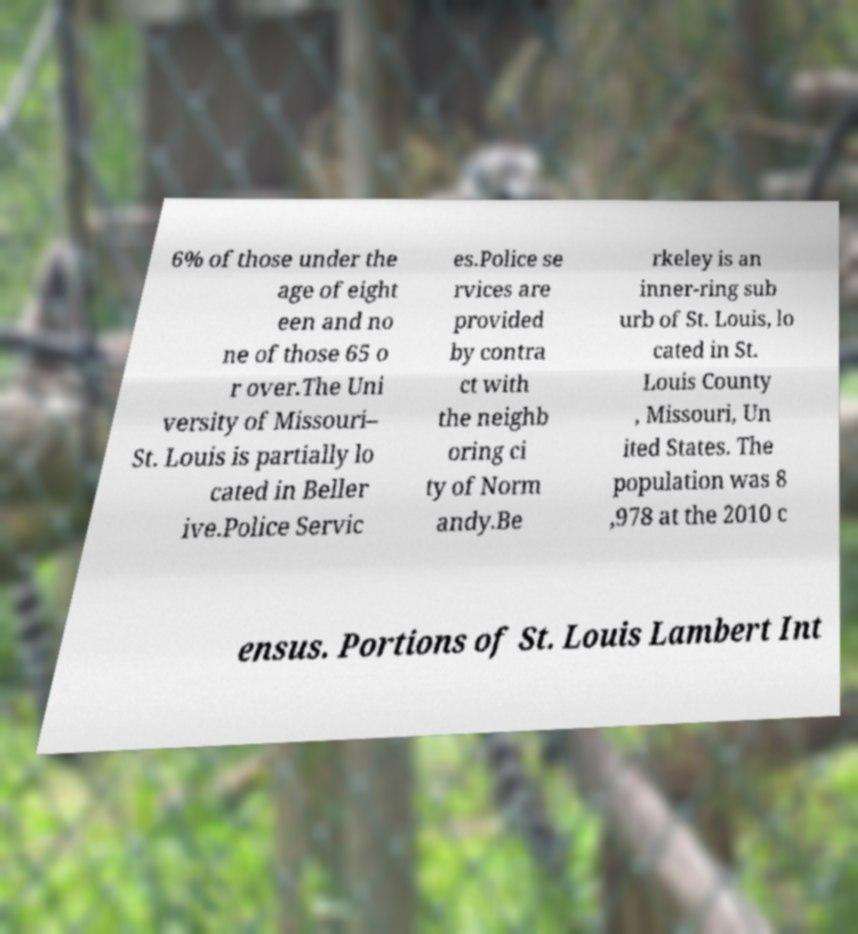For documentation purposes, I need the text within this image transcribed. Could you provide that? 6% of those under the age of eight een and no ne of those 65 o r over.The Uni versity of Missouri– St. Louis is partially lo cated in Beller ive.Police Servic es.Police se rvices are provided by contra ct with the neighb oring ci ty of Norm andy.Be rkeley is an inner-ring sub urb of St. Louis, lo cated in St. Louis County , Missouri, Un ited States. The population was 8 ,978 at the 2010 c ensus. Portions of St. Louis Lambert Int 